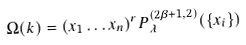Convert formula to latex. <formula><loc_0><loc_0><loc_500><loc_500>\Omega ( k ) = ( x _ { 1 } \dots x _ { n } ) ^ { r } P ^ { ( 2 \beta + 1 , 2 ) } _ { \lambda } ( \{ x _ { i } \} )</formula> 